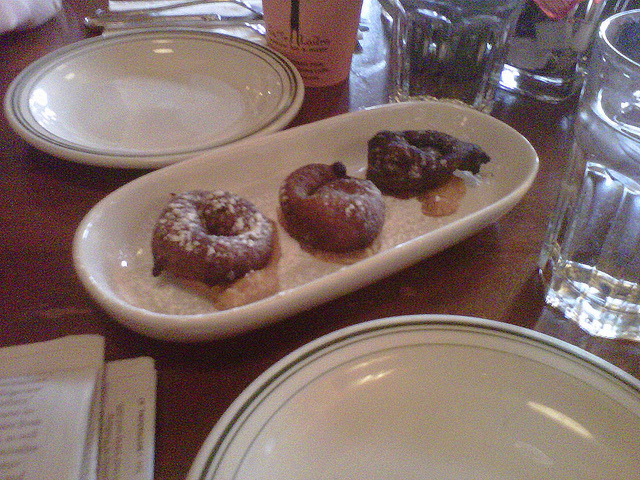What could be the occasion for these donuts? While one can only speculate without more context, these donuts could be for a casual breakfast or brunch given their presentation, or possibly a sweet treat during a coffee break. Is there anything else on the table that tells us more about the setting? Yes, there's a hot beverage cup which implies a sit-down meal or a coffee moment. The presence of empty plates and glasses suggests that either the meal has yet to start, or these are extras provided by the establishment. 